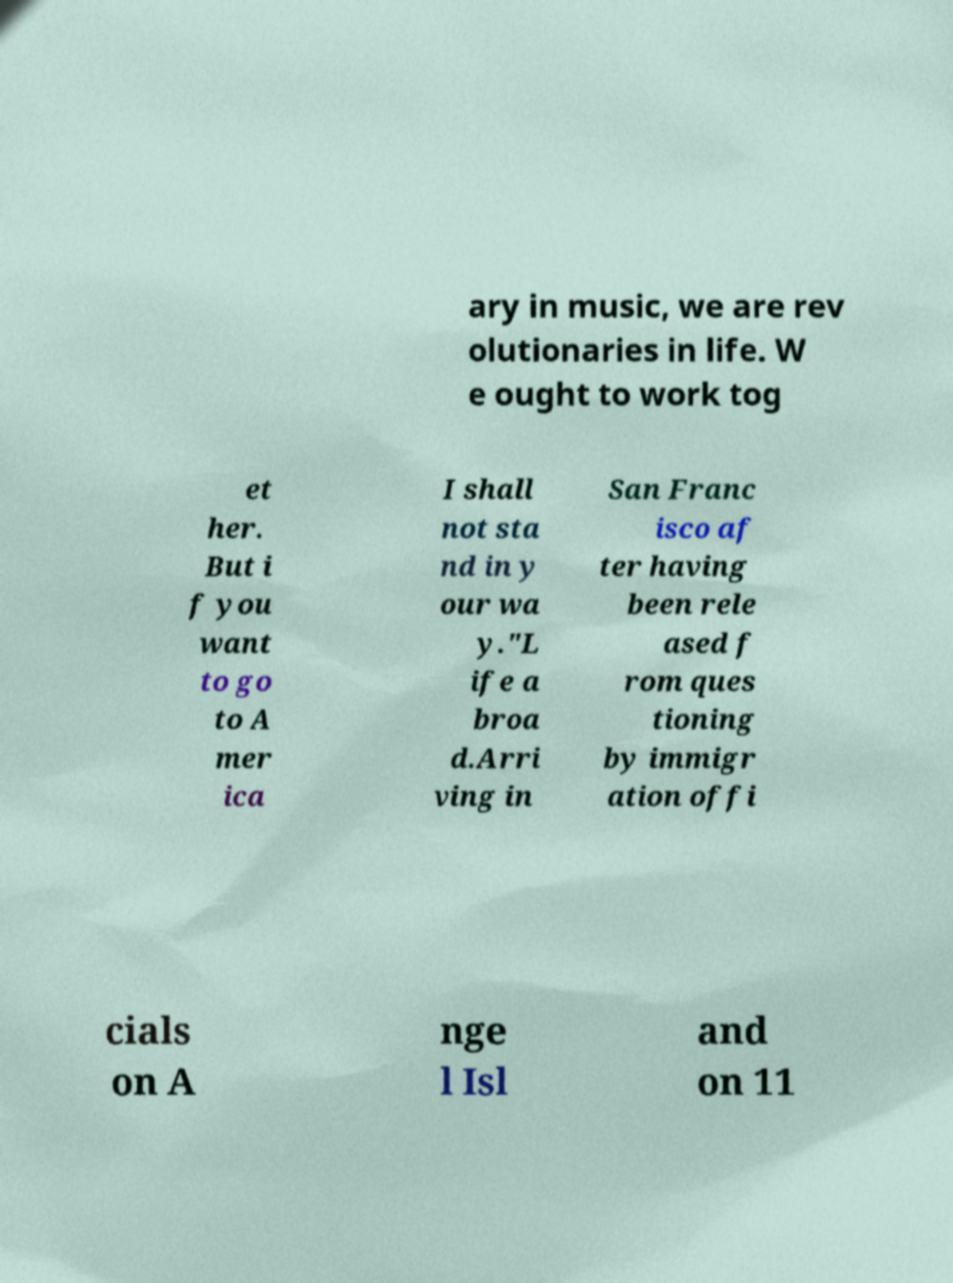There's text embedded in this image that I need extracted. Can you transcribe it verbatim? ary in music, we are rev olutionaries in life. W e ought to work tog et her. But i f you want to go to A mer ica I shall not sta nd in y our wa y."L ife a broa d.Arri ving in San Franc isco af ter having been rele ased f rom ques tioning by immigr ation offi cials on A nge l Isl and on 11 